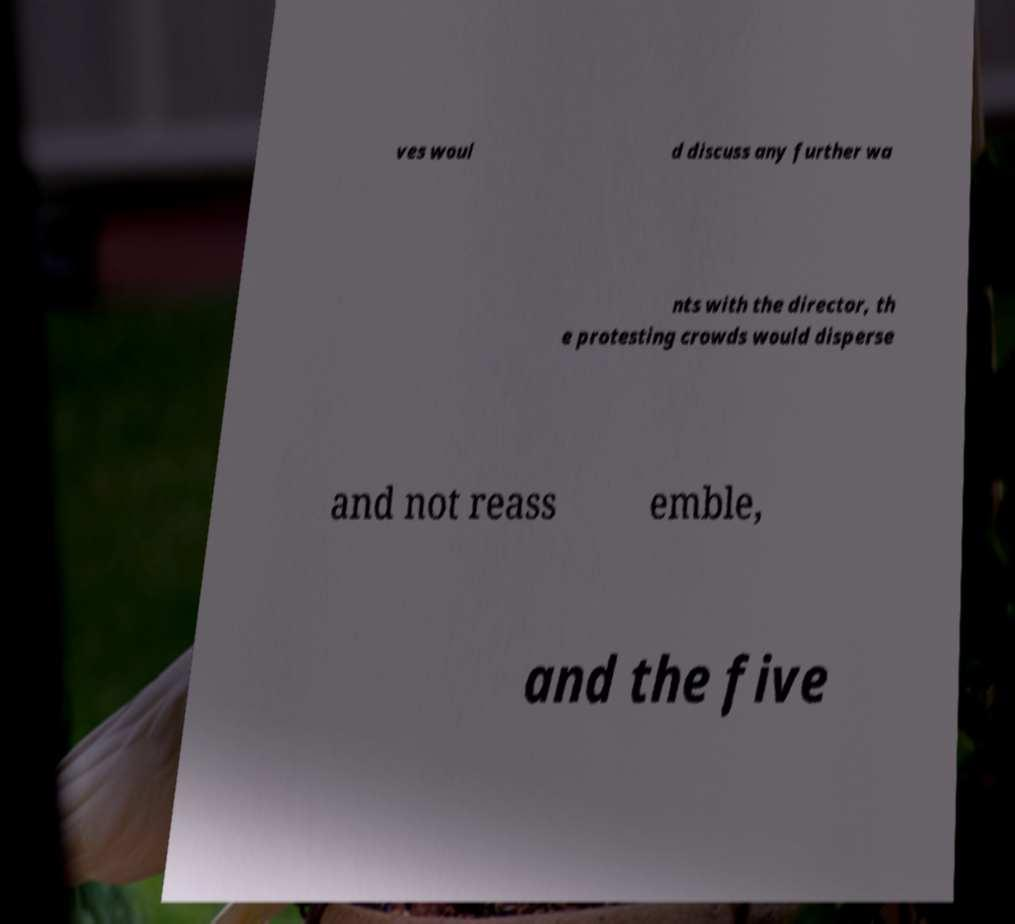There's text embedded in this image that I need extracted. Can you transcribe it verbatim? ves woul d discuss any further wa nts with the director, th e protesting crowds would disperse and not reass emble, and the five 